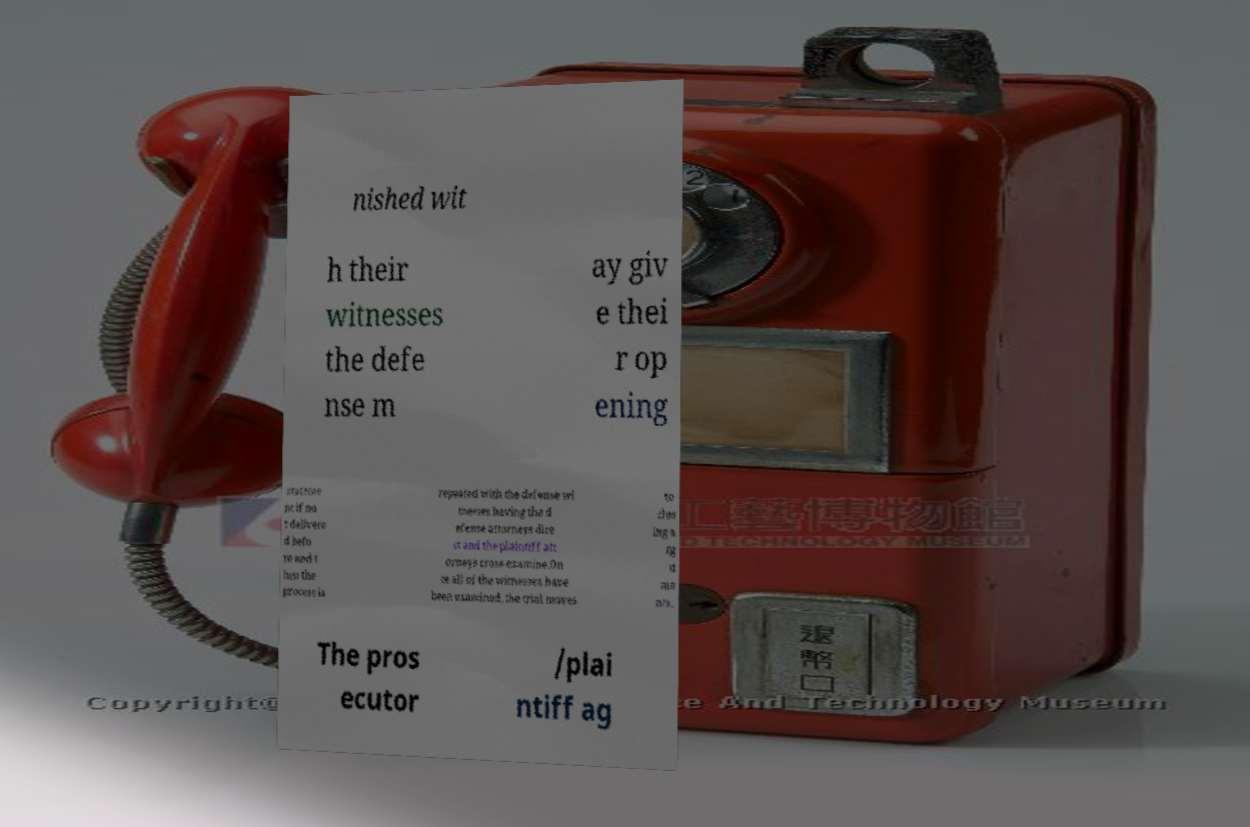What messages or text are displayed in this image? I need them in a readable, typed format. nished wit h their witnesses the defe nse m ay giv e thei r op ening stateme nt if no t delivere d befo re and t hen the process is repeated with the defense wi tnesses having the d efense attorneys dire ct and the plaintiff att orneys cross-examine.On ce all of the witnesses have been examined, the trial moves to clos ing a rg u me nts. The pros ecutor /plai ntiff ag 